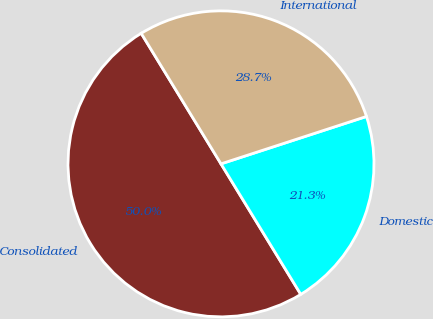Convert chart to OTSL. <chart><loc_0><loc_0><loc_500><loc_500><pie_chart><fcel>Consolidated<fcel>Domestic<fcel>International<nl><fcel>50.0%<fcel>21.28%<fcel>28.72%<nl></chart> 